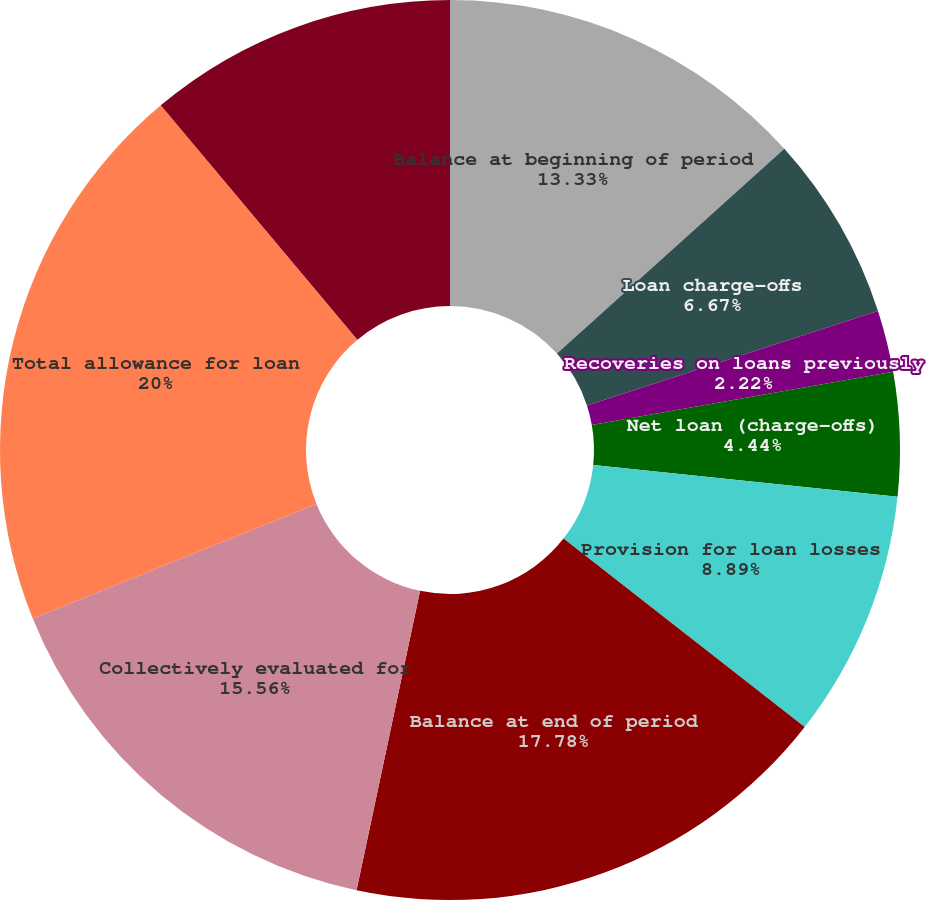<chart> <loc_0><loc_0><loc_500><loc_500><pie_chart><fcel>Balance at beginning of period<fcel>Loan charge-offs<fcel>Recoveries on loans previously<fcel>Net loan (charge-offs)<fcel>Provision for loan losses<fcel>Balance at end of period<fcel>As a percentage of total loans<fcel>Collectively evaluated for<fcel>Total allowance for loan<fcel>Individually evaluated for<nl><fcel>13.33%<fcel>6.67%<fcel>2.22%<fcel>4.44%<fcel>8.89%<fcel>17.78%<fcel>0.0%<fcel>15.56%<fcel>20.0%<fcel>11.11%<nl></chart> 